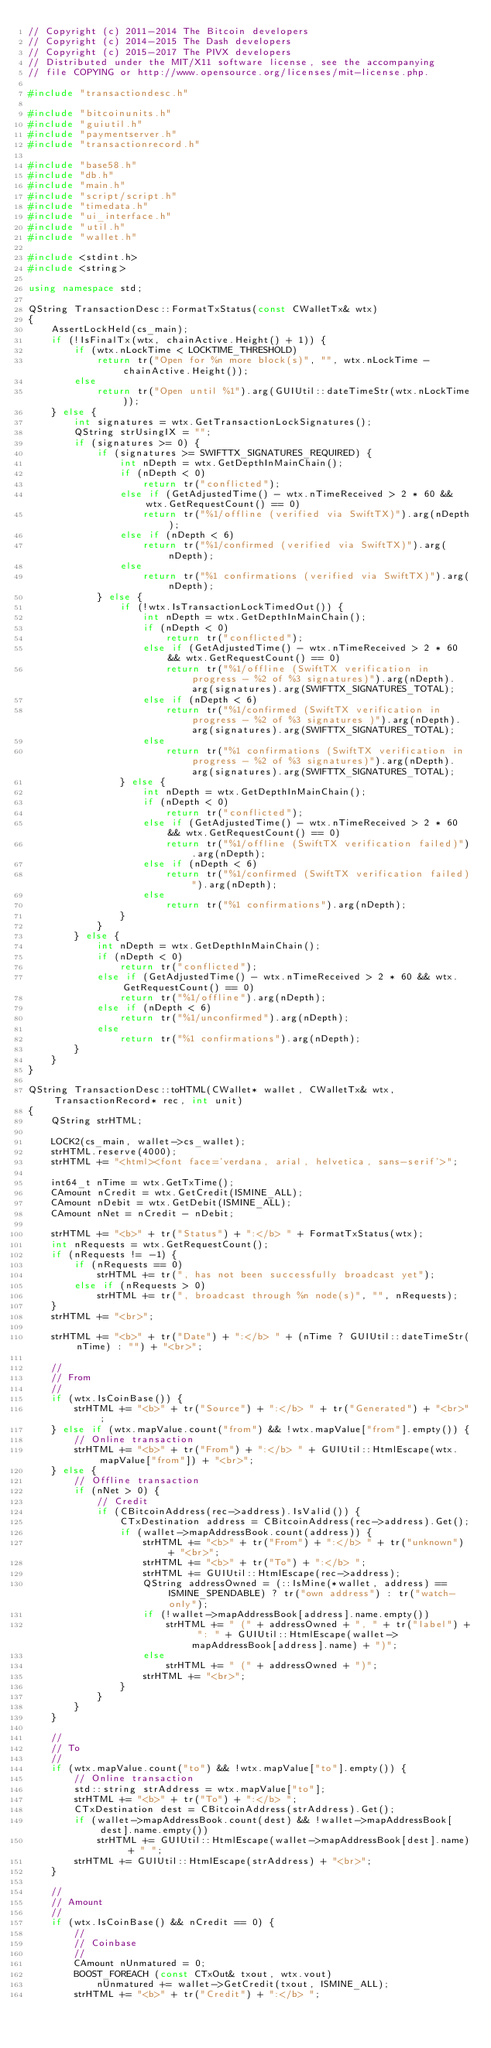<code> <loc_0><loc_0><loc_500><loc_500><_C++_>// Copyright (c) 2011-2014 The Bitcoin developers
// Copyright (c) 2014-2015 The Dash developers
// Copyright (c) 2015-2017 The PIVX developers
// Distributed under the MIT/X11 software license, see the accompanying
// file COPYING or http://www.opensource.org/licenses/mit-license.php.

#include "transactiondesc.h"

#include "bitcoinunits.h"
#include "guiutil.h"
#include "paymentserver.h"
#include "transactionrecord.h"

#include "base58.h"
#include "db.h"
#include "main.h"
#include "script/script.h"
#include "timedata.h"
#include "ui_interface.h"
#include "util.h"
#include "wallet.h"

#include <stdint.h>
#include <string>

using namespace std;

QString TransactionDesc::FormatTxStatus(const CWalletTx& wtx)
{
    AssertLockHeld(cs_main);
    if (!IsFinalTx(wtx, chainActive.Height() + 1)) {
        if (wtx.nLockTime < LOCKTIME_THRESHOLD)
            return tr("Open for %n more block(s)", "", wtx.nLockTime - chainActive.Height());
        else
            return tr("Open until %1").arg(GUIUtil::dateTimeStr(wtx.nLockTime));
    } else {
        int signatures = wtx.GetTransactionLockSignatures();
        QString strUsingIX = "";
        if (signatures >= 0) {
            if (signatures >= SWIFTTX_SIGNATURES_REQUIRED) {
                int nDepth = wtx.GetDepthInMainChain();
                if (nDepth < 0)
                    return tr("conflicted");
                else if (GetAdjustedTime() - wtx.nTimeReceived > 2 * 60 && wtx.GetRequestCount() == 0)
                    return tr("%1/offline (verified via SwiftTX)").arg(nDepth);
                else if (nDepth < 6)
                    return tr("%1/confirmed (verified via SwiftTX)").arg(nDepth);
                else
                    return tr("%1 confirmations (verified via SwiftTX)").arg(nDepth);
            } else {
                if (!wtx.IsTransactionLockTimedOut()) {
                    int nDepth = wtx.GetDepthInMainChain();
                    if (nDepth < 0)
                        return tr("conflicted");
                    else if (GetAdjustedTime() - wtx.nTimeReceived > 2 * 60 && wtx.GetRequestCount() == 0)
                        return tr("%1/offline (SwiftTX verification in progress - %2 of %3 signatures)").arg(nDepth).arg(signatures).arg(SWIFTTX_SIGNATURES_TOTAL);
                    else if (nDepth < 6)
                        return tr("%1/confirmed (SwiftTX verification in progress - %2 of %3 signatures )").arg(nDepth).arg(signatures).arg(SWIFTTX_SIGNATURES_TOTAL);
                    else
                        return tr("%1 confirmations (SwiftTX verification in progress - %2 of %3 signatures)").arg(nDepth).arg(signatures).arg(SWIFTTX_SIGNATURES_TOTAL);
                } else {
                    int nDepth = wtx.GetDepthInMainChain();
                    if (nDepth < 0)
                        return tr("conflicted");
                    else if (GetAdjustedTime() - wtx.nTimeReceived > 2 * 60 && wtx.GetRequestCount() == 0)
                        return tr("%1/offline (SwiftTX verification failed)").arg(nDepth);
                    else if (nDepth < 6)
                        return tr("%1/confirmed (SwiftTX verification failed)").arg(nDepth);
                    else
                        return tr("%1 confirmations").arg(nDepth);
                }
            }
        } else {
            int nDepth = wtx.GetDepthInMainChain();
            if (nDepth < 0)
                return tr("conflicted");
            else if (GetAdjustedTime() - wtx.nTimeReceived > 2 * 60 && wtx.GetRequestCount() == 0)
                return tr("%1/offline").arg(nDepth);
            else if (nDepth < 6)
                return tr("%1/unconfirmed").arg(nDepth);
            else
                return tr("%1 confirmations").arg(nDepth);
        }
    }
}

QString TransactionDesc::toHTML(CWallet* wallet, CWalletTx& wtx, TransactionRecord* rec, int unit)
{
    QString strHTML;

    LOCK2(cs_main, wallet->cs_wallet);
    strHTML.reserve(4000);
    strHTML += "<html><font face='verdana, arial, helvetica, sans-serif'>";

    int64_t nTime = wtx.GetTxTime();
    CAmount nCredit = wtx.GetCredit(ISMINE_ALL);
    CAmount nDebit = wtx.GetDebit(ISMINE_ALL);
    CAmount nNet = nCredit - nDebit;

    strHTML += "<b>" + tr("Status") + ":</b> " + FormatTxStatus(wtx);
    int nRequests = wtx.GetRequestCount();
    if (nRequests != -1) {
        if (nRequests == 0)
            strHTML += tr(", has not been successfully broadcast yet");
        else if (nRequests > 0)
            strHTML += tr(", broadcast through %n node(s)", "", nRequests);
    }
    strHTML += "<br>";

    strHTML += "<b>" + tr("Date") + ":</b> " + (nTime ? GUIUtil::dateTimeStr(nTime) : "") + "<br>";

    //
    // From
    //
    if (wtx.IsCoinBase()) {
        strHTML += "<b>" + tr("Source") + ":</b> " + tr("Generated") + "<br>";
    } else if (wtx.mapValue.count("from") && !wtx.mapValue["from"].empty()) {
        // Online transaction
        strHTML += "<b>" + tr("From") + ":</b> " + GUIUtil::HtmlEscape(wtx.mapValue["from"]) + "<br>";
    } else {
        // Offline transaction
        if (nNet > 0) {
            // Credit
            if (CBitcoinAddress(rec->address).IsValid()) {
                CTxDestination address = CBitcoinAddress(rec->address).Get();
                if (wallet->mapAddressBook.count(address)) {
                    strHTML += "<b>" + tr("From") + ":</b> " + tr("unknown") + "<br>";
                    strHTML += "<b>" + tr("To") + ":</b> ";
                    strHTML += GUIUtil::HtmlEscape(rec->address);
                    QString addressOwned = (::IsMine(*wallet, address) == ISMINE_SPENDABLE) ? tr("own address") : tr("watch-only");
                    if (!wallet->mapAddressBook[address].name.empty())
                        strHTML += " (" + addressOwned + ", " + tr("label") + ": " + GUIUtil::HtmlEscape(wallet->mapAddressBook[address].name) + ")";
                    else
                        strHTML += " (" + addressOwned + ")";
                    strHTML += "<br>";
                }
            }
        }
    }

    //
    // To
    //
    if (wtx.mapValue.count("to") && !wtx.mapValue["to"].empty()) {
        // Online transaction
        std::string strAddress = wtx.mapValue["to"];
        strHTML += "<b>" + tr("To") + ":</b> ";
        CTxDestination dest = CBitcoinAddress(strAddress).Get();
        if (wallet->mapAddressBook.count(dest) && !wallet->mapAddressBook[dest].name.empty())
            strHTML += GUIUtil::HtmlEscape(wallet->mapAddressBook[dest].name) + " ";
        strHTML += GUIUtil::HtmlEscape(strAddress) + "<br>";
    }

    //
    // Amount
    //
    if (wtx.IsCoinBase() && nCredit == 0) {
        //
        // Coinbase
        //
        CAmount nUnmatured = 0;
        BOOST_FOREACH (const CTxOut& txout, wtx.vout)
            nUnmatured += wallet->GetCredit(txout, ISMINE_ALL);
        strHTML += "<b>" + tr("Credit") + ":</b> ";</code> 